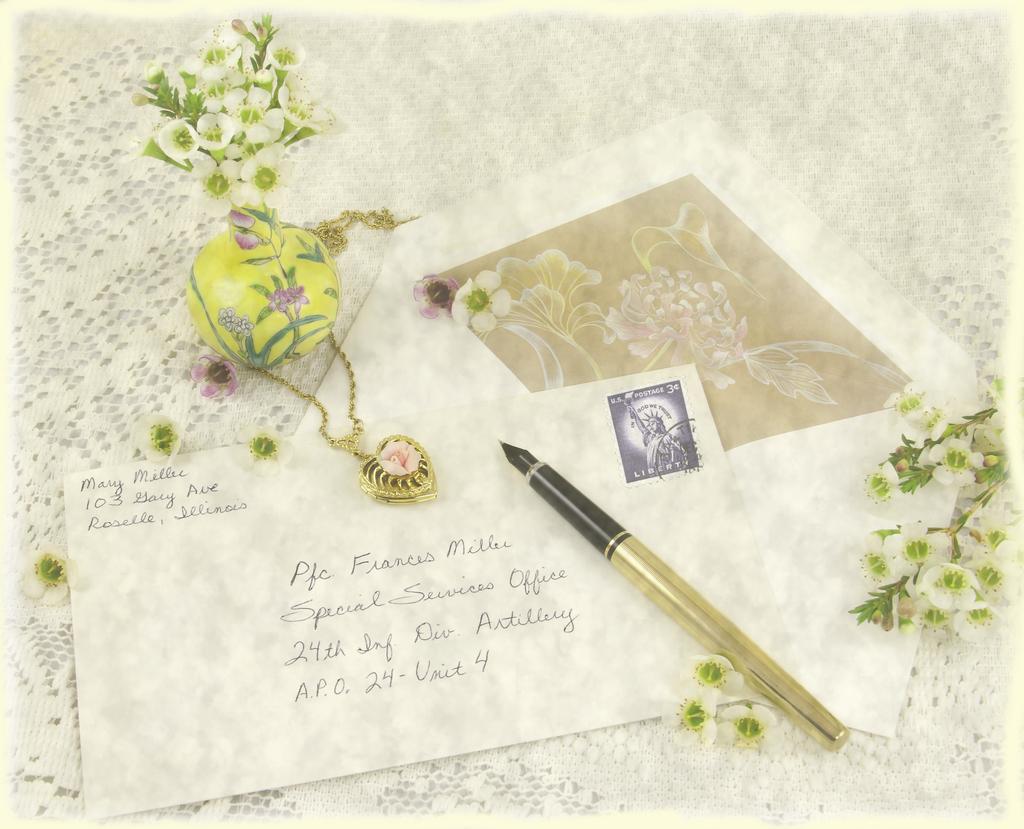Who is the mail to?
Give a very brief answer. Pfc francis miller. Who is mailing this letter?
Offer a terse response. Mary miller. 